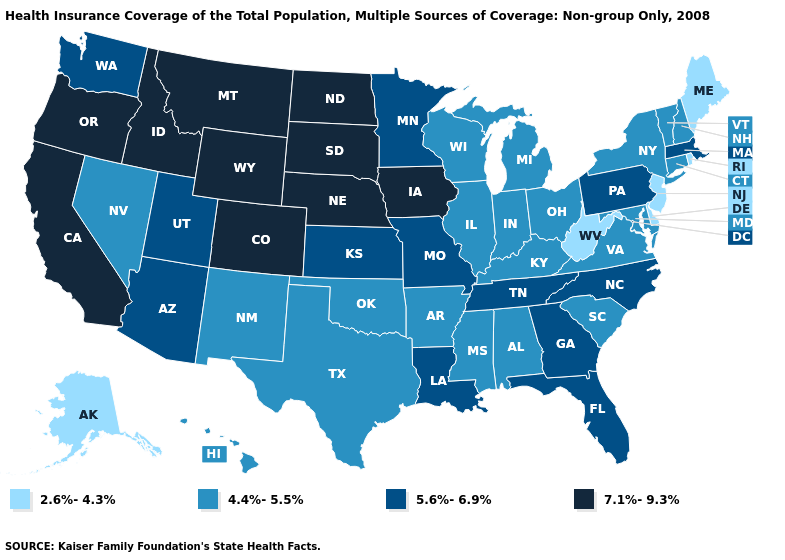Which states have the lowest value in the South?
Concise answer only. Delaware, West Virginia. Among the states that border North Carolina , which have the highest value?
Write a very short answer. Georgia, Tennessee. Name the states that have a value in the range 5.6%-6.9%?
Write a very short answer. Arizona, Florida, Georgia, Kansas, Louisiana, Massachusetts, Minnesota, Missouri, North Carolina, Pennsylvania, Tennessee, Utah, Washington. Does the first symbol in the legend represent the smallest category?
Concise answer only. Yes. Name the states that have a value in the range 5.6%-6.9%?
Be succinct. Arizona, Florida, Georgia, Kansas, Louisiana, Massachusetts, Minnesota, Missouri, North Carolina, Pennsylvania, Tennessee, Utah, Washington. Does Kentucky have a higher value than Louisiana?
Be succinct. No. What is the highest value in the USA?
Give a very brief answer. 7.1%-9.3%. Name the states that have a value in the range 4.4%-5.5%?
Keep it brief. Alabama, Arkansas, Connecticut, Hawaii, Illinois, Indiana, Kentucky, Maryland, Michigan, Mississippi, Nevada, New Hampshire, New Mexico, New York, Ohio, Oklahoma, South Carolina, Texas, Vermont, Virginia, Wisconsin. Does Oregon have the highest value in the USA?
Be succinct. Yes. Which states have the lowest value in the USA?
Short answer required. Alaska, Delaware, Maine, New Jersey, Rhode Island, West Virginia. Name the states that have a value in the range 4.4%-5.5%?
Keep it brief. Alabama, Arkansas, Connecticut, Hawaii, Illinois, Indiana, Kentucky, Maryland, Michigan, Mississippi, Nevada, New Hampshire, New Mexico, New York, Ohio, Oklahoma, South Carolina, Texas, Vermont, Virginia, Wisconsin. What is the value of Mississippi?
Keep it brief. 4.4%-5.5%. Name the states that have a value in the range 4.4%-5.5%?
Be succinct. Alabama, Arkansas, Connecticut, Hawaii, Illinois, Indiana, Kentucky, Maryland, Michigan, Mississippi, Nevada, New Hampshire, New Mexico, New York, Ohio, Oklahoma, South Carolina, Texas, Vermont, Virginia, Wisconsin. Among the states that border Mississippi , which have the highest value?
Short answer required. Louisiana, Tennessee. What is the value of Arkansas?
Give a very brief answer. 4.4%-5.5%. 